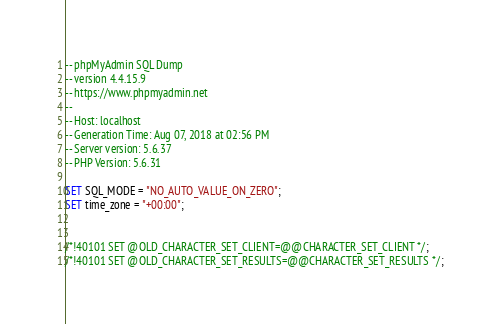Convert code to text. <code><loc_0><loc_0><loc_500><loc_500><_SQL_>-- phpMyAdmin SQL Dump
-- version 4.4.15.9
-- https://www.phpmyadmin.net
--
-- Host: localhost
-- Generation Time: Aug 07, 2018 at 02:56 PM
-- Server version: 5.6.37
-- PHP Version: 5.6.31

SET SQL_MODE = "NO_AUTO_VALUE_ON_ZERO";
SET time_zone = "+00:00";


/*!40101 SET @OLD_CHARACTER_SET_CLIENT=@@CHARACTER_SET_CLIENT */;
/*!40101 SET @OLD_CHARACTER_SET_RESULTS=@@CHARACTER_SET_RESULTS */;</code> 